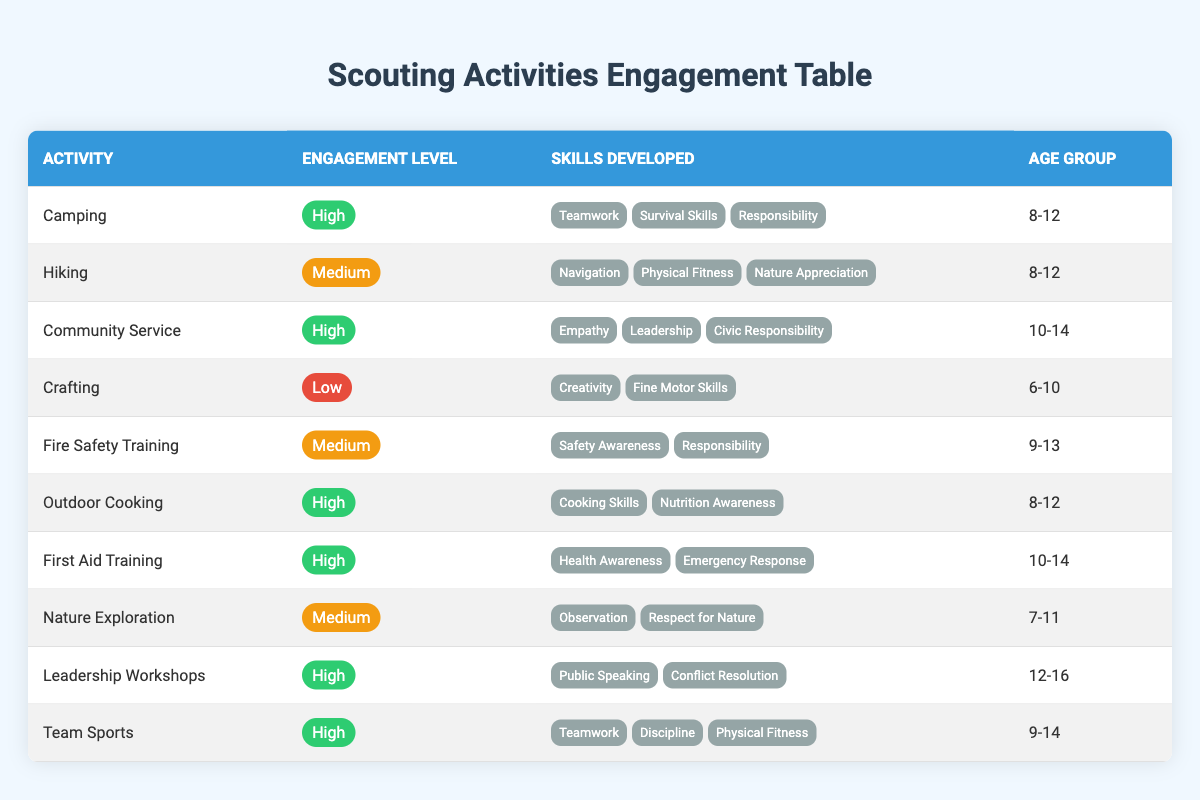What is the activity with the highest engagement level? The activities marked with "High" engagement level are Camping, Community Service, Outdoor Cooking, First Aid Training, Leadership Workshops, and Team Sports. However, since we are looking for a specific activity with the highest engagement level, any of these activities fit this criterion, but the question doesn't specify to choose one. Hence, we can mention any of these.
Answer: Camping Which activities are designed for the age group 10-14? Looking through the age group column, the activities for the age range 10-14 are Community Service, First Aid Training, and Leadership Workshops.
Answer: Community Service, First Aid Training, Leadership Workshops How many activities have a medium engagement level? There are three activities tagged with "Medium" engagement level which includes Hiking, Fire Safety Training, and Nature Exploration. Therefore, the total count of such activities is 3.
Answer: 3 Is crafting included in the activities with a high engagement level? The activity of crafting is listed with a "Low" engagement level, therefore it is not included in the high engagement category.
Answer: No What skills are developed in outdoor cooking? The table shows that the skills developed in outdoor cooking include Cooking Skills and Nutrition Awareness.
Answer: Cooking Skills, Nutrition Awareness How many activities develop teamwork skills? The activities that develop teamwork skills are Camping, Team Sports, and Leadership Workshops, so we sum them up and find there are 3 activities that focus on developing teamwork skills.
Answer: 3 What is the average engagement level across all activities? The engagement levels can be assigned numerical values: High = 3, Medium = 2, Low = 1. Counting each, we get: 6 High, 3 Medium, 1 Low, giving us a total of 6*3 + 3*2 + 1*1 = 20 total points with 10 activities. Therefore, the average engagement level is 20/10 = 2.
Answer: 2 